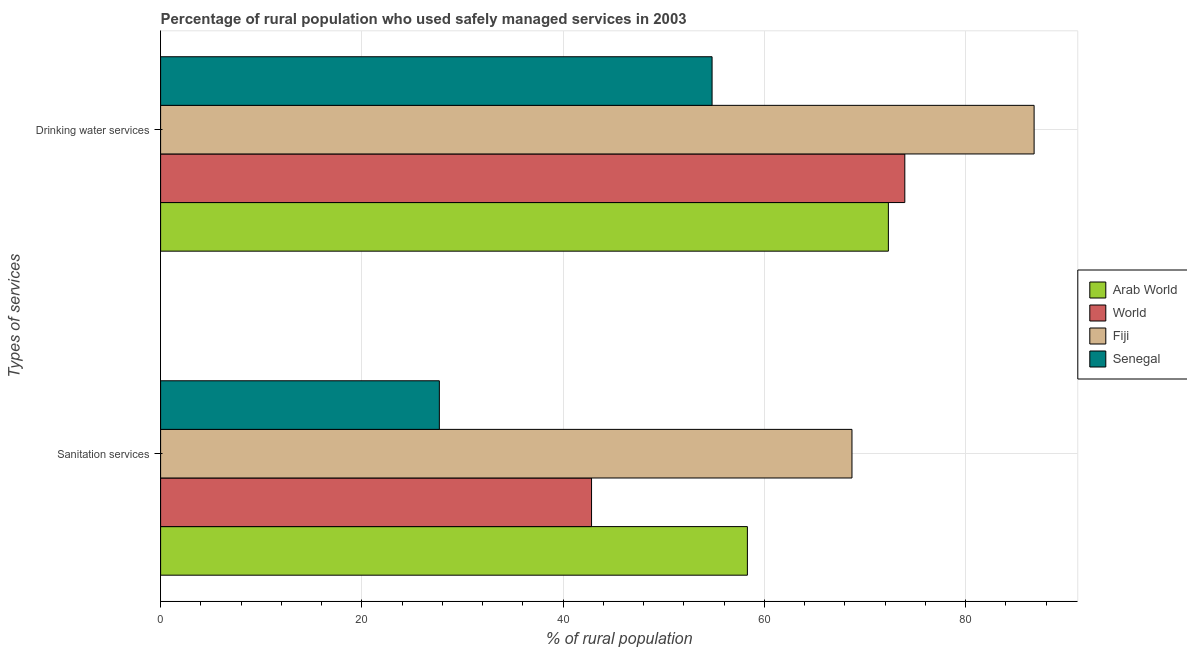How many different coloured bars are there?
Ensure brevity in your answer.  4. Are the number of bars per tick equal to the number of legend labels?
Provide a short and direct response. Yes. Are the number of bars on each tick of the Y-axis equal?
Ensure brevity in your answer.  Yes. How many bars are there on the 2nd tick from the bottom?
Your response must be concise. 4. What is the label of the 2nd group of bars from the top?
Keep it short and to the point. Sanitation services. What is the percentage of rural population who used drinking water services in Fiji?
Provide a short and direct response. 86.8. Across all countries, what is the maximum percentage of rural population who used drinking water services?
Offer a terse response. 86.8. Across all countries, what is the minimum percentage of rural population who used drinking water services?
Offer a terse response. 54.8. In which country was the percentage of rural population who used drinking water services maximum?
Make the answer very short. Fiji. In which country was the percentage of rural population who used drinking water services minimum?
Your answer should be very brief. Senegal. What is the total percentage of rural population who used sanitation services in the graph?
Give a very brief answer. 197.53. What is the difference between the percentage of rural population who used sanitation services in World and that in Arab World?
Your answer should be very brief. -15.49. What is the difference between the percentage of rural population who used sanitation services in Arab World and the percentage of rural population who used drinking water services in World?
Make the answer very short. -15.64. What is the average percentage of rural population who used sanitation services per country?
Make the answer very short. 49.38. What is the difference between the percentage of rural population who used sanitation services and percentage of rural population who used drinking water services in Fiji?
Offer a terse response. -18.1. What is the ratio of the percentage of rural population who used sanitation services in Arab World to that in World?
Ensure brevity in your answer.  1.36. In how many countries, is the percentage of rural population who used sanitation services greater than the average percentage of rural population who used sanitation services taken over all countries?
Your answer should be very brief. 2. What does the 2nd bar from the top in Sanitation services represents?
Your response must be concise. Fiji. What does the 1st bar from the bottom in Sanitation services represents?
Offer a terse response. Arab World. How many bars are there?
Offer a very short reply. 8. Are all the bars in the graph horizontal?
Your answer should be very brief. Yes. How many countries are there in the graph?
Offer a terse response. 4. Are the values on the major ticks of X-axis written in scientific E-notation?
Your answer should be compact. No. Does the graph contain grids?
Provide a short and direct response. Yes. Where does the legend appear in the graph?
Keep it short and to the point. Center right. What is the title of the graph?
Provide a short and direct response. Percentage of rural population who used safely managed services in 2003. Does "Tajikistan" appear as one of the legend labels in the graph?
Your response must be concise. No. What is the label or title of the X-axis?
Make the answer very short. % of rural population. What is the label or title of the Y-axis?
Your response must be concise. Types of services. What is the % of rural population of Arab World in Sanitation services?
Offer a terse response. 58.31. What is the % of rural population in World in Sanitation services?
Make the answer very short. 42.82. What is the % of rural population of Fiji in Sanitation services?
Ensure brevity in your answer.  68.7. What is the % of rural population in Senegal in Sanitation services?
Offer a terse response. 27.7. What is the % of rural population in Arab World in Drinking water services?
Offer a terse response. 72.32. What is the % of rural population in World in Drinking water services?
Ensure brevity in your answer.  73.95. What is the % of rural population of Fiji in Drinking water services?
Keep it short and to the point. 86.8. What is the % of rural population of Senegal in Drinking water services?
Offer a very short reply. 54.8. Across all Types of services, what is the maximum % of rural population of Arab World?
Your answer should be compact. 72.32. Across all Types of services, what is the maximum % of rural population of World?
Offer a very short reply. 73.95. Across all Types of services, what is the maximum % of rural population in Fiji?
Ensure brevity in your answer.  86.8. Across all Types of services, what is the maximum % of rural population of Senegal?
Provide a short and direct response. 54.8. Across all Types of services, what is the minimum % of rural population of Arab World?
Provide a short and direct response. 58.31. Across all Types of services, what is the minimum % of rural population in World?
Provide a succinct answer. 42.82. Across all Types of services, what is the minimum % of rural population in Fiji?
Offer a very short reply. 68.7. Across all Types of services, what is the minimum % of rural population of Senegal?
Ensure brevity in your answer.  27.7. What is the total % of rural population in Arab World in the graph?
Offer a terse response. 130.63. What is the total % of rural population in World in the graph?
Offer a terse response. 116.77. What is the total % of rural population of Fiji in the graph?
Give a very brief answer. 155.5. What is the total % of rural population of Senegal in the graph?
Give a very brief answer. 82.5. What is the difference between the % of rural population of Arab World in Sanitation services and that in Drinking water services?
Provide a short and direct response. -14.01. What is the difference between the % of rural population in World in Sanitation services and that in Drinking water services?
Give a very brief answer. -31.13. What is the difference between the % of rural population of Fiji in Sanitation services and that in Drinking water services?
Make the answer very short. -18.1. What is the difference between the % of rural population of Senegal in Sanitation services and that in Drinking water services?
Keep it short and to the point. -27.1. What is the difference between the % of rural population of Arab World in Sanitation services and the % of rural population of World in Drinking water services?
Your response must be concise. -15.64. What is the difference between the % of rural population of Arab World in Sanitation services and the % of rural population of Fiji in Drinking water services?
Offer a very short reply. -28.49. What is the difference between the % of rural population of Arab World in Sanitation services and the % of rural population of Senegal in Drinking water services?
Your answer should be compact. 3.51. What is the difference between the % of rural population in World in Sanitation services and the % of rural population in Fiji in Drinking water services?
Your response must be concise. -43.98. What is the difference between the % of rural population of World in Sanitation services and the % of rural population of Senegal in Drinking water services?
Make the answer very short. -11.98. What is the difference between the % of rural population of Fiji in Sanitation services and the % of rural population of Senegal in Drinking water services?
Your response must be concise. 13.9. What is the average % of rural population in Arab World per Types of services?
Provide a short and direct response. 65.31. What is the average % of rural population of World per Types of services?
Make the answer very short. 58.39. What is the average % of rural population in Fiji per Types of services?
Your answer should be very brief. 77.75. What is the average % of rural population of Senegal per Types of services?
Make the answer very short. 41.25. What is the difference between the % of rural population of Arab World and % of rural population of World in Sanitation services?
Give a very brief answer. 15.49. What is the difference between the % of rural population of Arab World and % of rural population of Fiji in Sanitation services?
Give a very brief answer. -10.39. What is the difference between the % of rural population in Arab World and % of rural population in Senegal in Sanitation services?
Keep it short and to the point. 30.61. What is the difference between the % of rural population in World and % of rural population in Fiji in Sanitation services?
Ensure brevity in your answer.  -25.88. What is the difference between the % of rural population of World and % of rural population of Senegal in Sanitation services?
Offer a very short reply. 15.12. What is the difference between the % of rural population in Arab World and % of rural population in World in Drinking water services?
Your answer should be very brief. -1.63. What is the difference between the % of rural population in Arab World and % of rural population in Fiji in Drinking water services?
Your response must be concise. -14.48. What is the difference between the % of rural population in Arab World and % of rural population in Senegal in Drinking water services?
Your answer should be very brief. 17.52. What is the difference between the % of rural population of World and % of rural population of Fiji in Drinking water services?
Make the answer very short. -12.85. What is the difference between the % of rural population of World and % of rural population of Senegal in Drinking water services?
Your answer should be compact. 19.15. What is the ratio of the % of rural population of Arab World in Sanitation services to that in Drinking water services?
Your answer should be compact. 0.81. What is the ratio of the % of rural population of World in Sanitation services to that in Drinking water services?
Give a very brief answer. 0.58. What is the ratio of the % of rural population in Fiji in Sanitation services to that in Drinking water services?
Your answer should be very brief. 0.79. What is the ratio of the % of rural population of Senegal in Sanitation services to that in Drinking water services?
Your answer should be very brief. 0.51. What is the difference between the highest and the second highest % of rural population in Arab World?
Provide a succinct answer. 14.01. What is the difference between the highest and the second highest % of rural population in World?
Give a very brief answer. 31.13. What is the difference between the highest and the second highest % of rural population in Senegal?
Your answer should be compact. 27.1. What is the difference between the highest and the lowest % of rural population in Arab World?
Ensure brevity in your answer.  14.01. What is the difference between the highest and the lowest % of rural population of World?
Offer a terse response. 31.13. What is the difference between the highest and the lowest % of rural population in Fiji?
Your answer should be compact. 18.1. What is the difference between the highest and the lowest % of rural population of Senegal?
Your response must be concise. 27.1. 